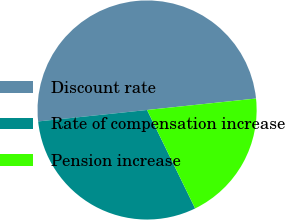Convert chart to OTSL. <chart><loc_0><loc_0><loc_500><loc_500><pie_chart><fcel>Discount rate<fcel>Rate of compensation increase<fcel>Pension increase<nl><fcel>50.0%<fcel>30.56%<fcel>19.44%<nl></chart> 